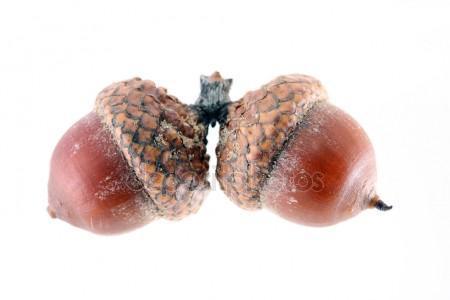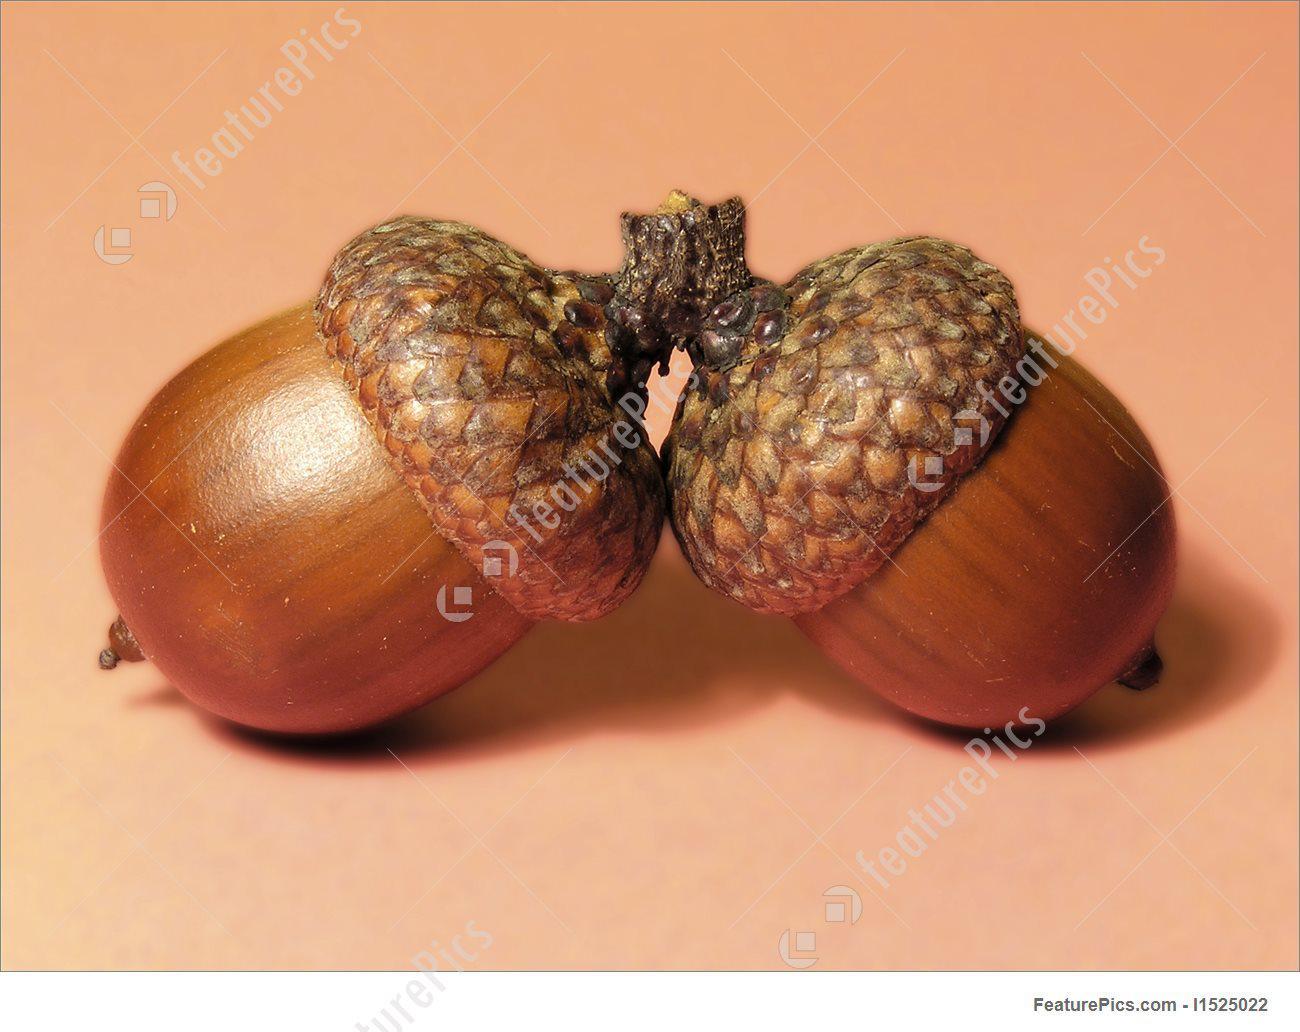The first image is the image on the left, the second image is the image on the right. Considering the images on both sides, is "Each image contains exactly two acorns with their caps on, and at least one of the images features acorns with caps back-to-back and joined at the stem top." valid? Answer yes or no. Yes. The first image is the image on the left, the second image is the image on the right. Considering the images on both sides, is "The left and right image contains the same number of real acorns." valid? Answer yes or no. Yes. 